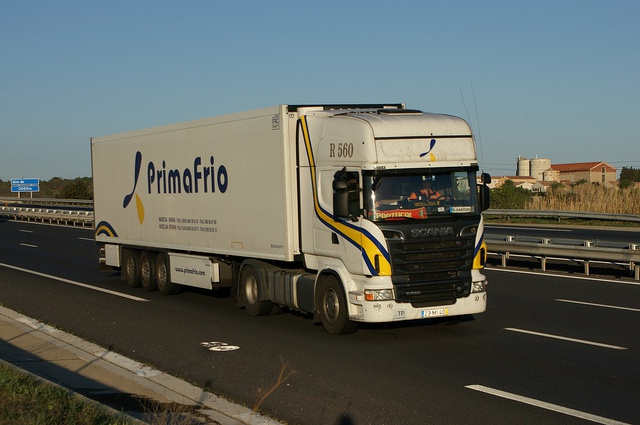Describe the objects in this image and their specific colors. I can see truck in gray, black, darkgray, and tan tones and people in gray, black, brown, maroon, and red tones in this image. 